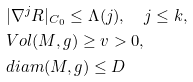<formula> <loc_0><loc_0><loc_500><loc_500>& | \nabla ^ { j } R | _ { C _ { 0 } } \leq \Lambda ( j ) , \quad j \leq k , \\ & V o l ( M , g ) \geq v > 0 , \\ & d i a m ( M , g ) \leq D</formula> 